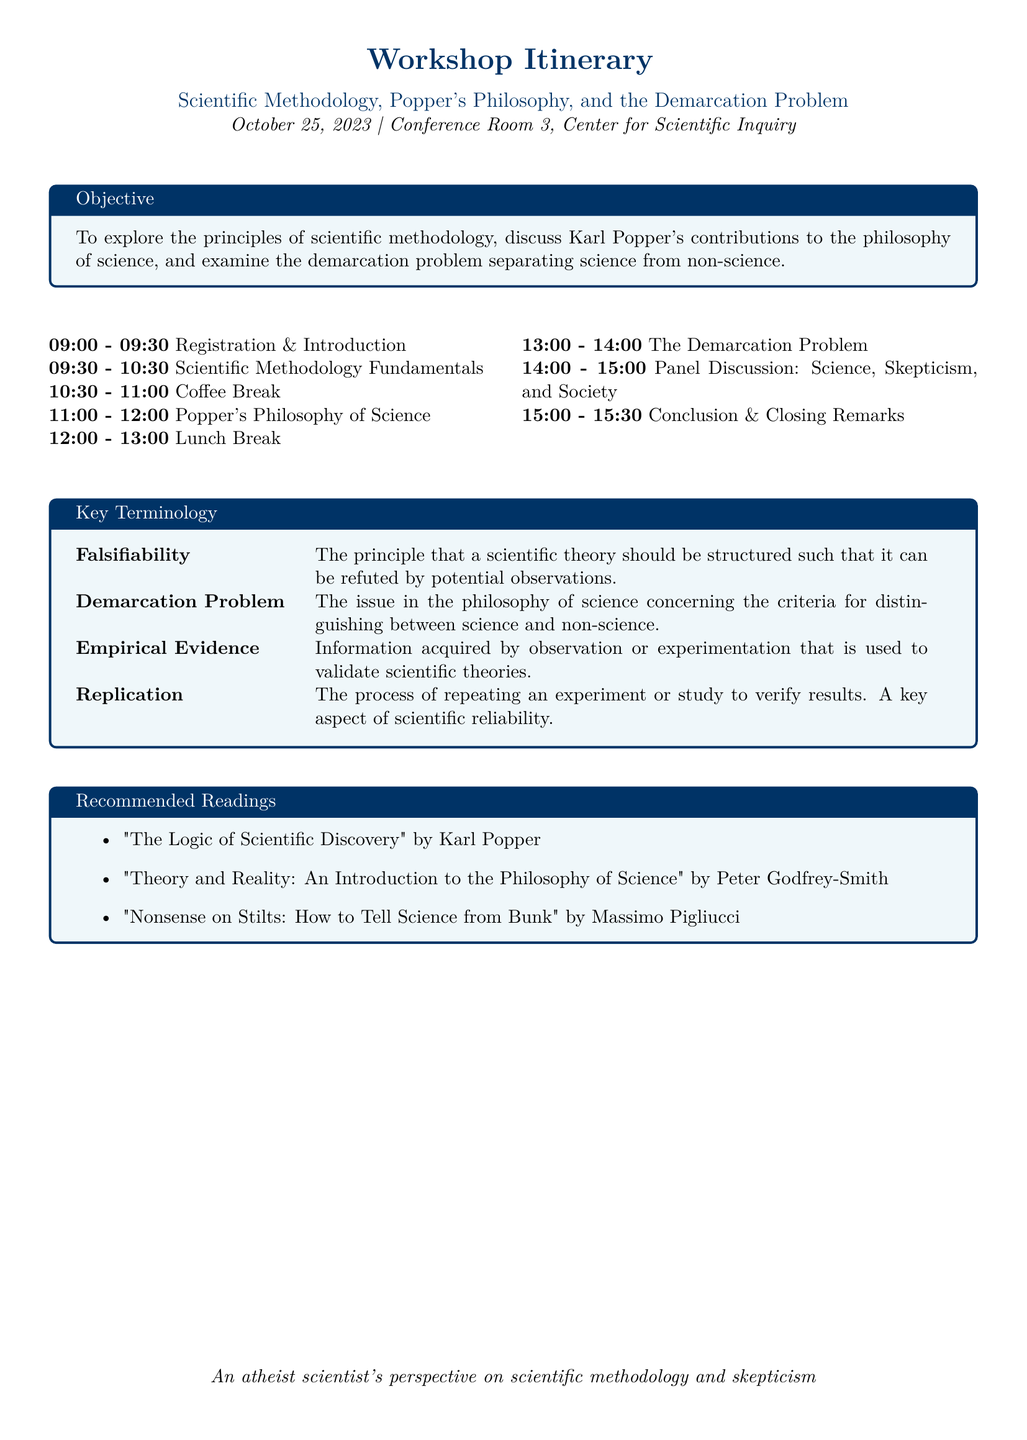What is the date of the workshop? The date of the workshop is clearly stated in the document, which is October 25, 2023.
Answer: October 25, 2023 What is the first agenda item listed? The first agenda item mentioned in the itinerary is "Registration & Introduction."
Answer: Registration & Introduction Who is the author of "The Logic of Scientific Discovery"? The author of "The Logic of Scientific Discovery" is Karl Popper, as indicated in the recommended readings section.
Answer: Karl Popper What is the objective of the workshop? The objective of the workshop is to explore principles of scientific methodology, Popper's contributions, and the demarcation problem.
Answer: To explore the principles of scientific methodology, discuss Karl Popper's contributions to the philosophy of science, and examine the demarcation problem separating science from non-science What is a key aspect of scientific reliability mentioned in the document? The document mentions "Replication" as a key aspect of scientific reliability.
Answer: Replication What is the time duration of the coffee break? The coffee break is scheduled for a duration of 30 minutes, from 10:30 to 11:00.
Answer: 30 minutes Which topic is scheduled after lunch? The topic scheduled after lunch is "The Demarcation Problem."
Answer: The Demarcation Problem What philosophical issue does the demarcation problem concern? The demarcation problem concerns criteria for distinguishing between science and non-science.
Answer: Criteria for distinguishing between science and non-science 